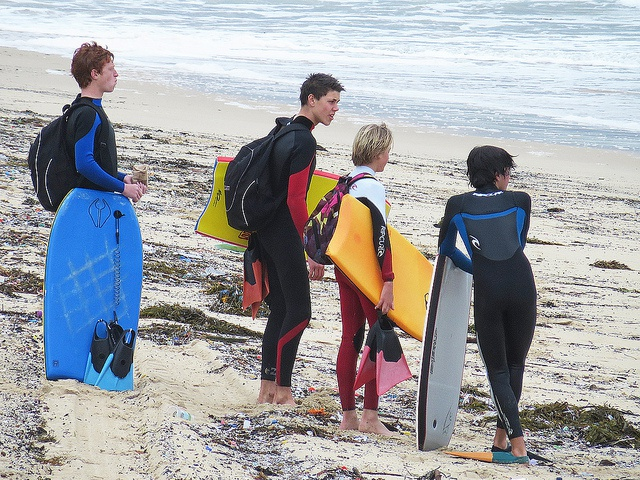Describe the objects in this image and their specific colors. I can see surfboard in lightgray, blue, gray, lightblue, and black tones, people in lightgray, black, navy, darkblue, and gray tones, people in lightgray, black, gray, and brown tones, people in lightgray, maroon, black, and gray tones, and surfboard in lightgray, orange, gold, and red tones in this image. 